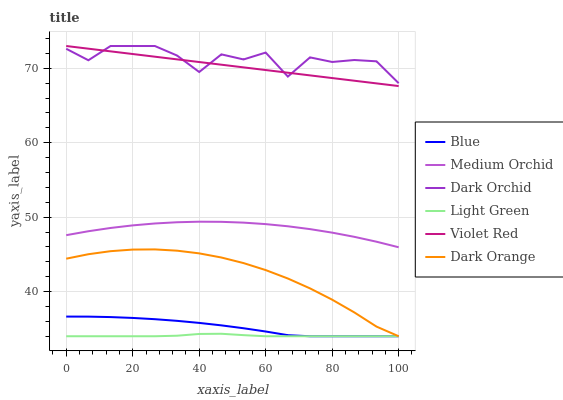Does Light Green have the minimum area under the curve?
Answer yes or no. Yes. Does Dark Orchid have the maximum area under the curve?
Answer yes or no. Yes. Does Dark Orange have the minimum area under the curve?
Answer yes or no. No. Does Dark Orange have the maximum area under the curve?
Answer yes or no. No. Is Violet Red the smoothest?
Answer yes or no. Yes. Is Dark Orchid the roughest?
Answer yes or no. Yes. Is Dark Orange the smoothest?
Answer yes or no. No. Is Dark Orange the roughest?
Answer yes or no. No. Does Blue have the lowest value?
Answer yes or no. Yes. Does Violet Red have the lowest value?
Answer yes or no. No. Does Dark Orchid have the highest value?
Answer yes or no. Yes. Does Dark Orange have the highest value?
Answer yes or no. No. Is Medium Orchid less than Violet Red?
Answer yes or no. Yes. Is Dark Orchid greater than Light Green?
Answer yes or no. Yes. Does Blue intersect Light Green?
Answer yes or no. Yes. Is Blue less than Light Green?
Answer yes or no. No. Is Blue greater than Light Green?
Answer yes or no. No. Does Medium Orchid intersect Violet Red?
Answer yes or no. No. 